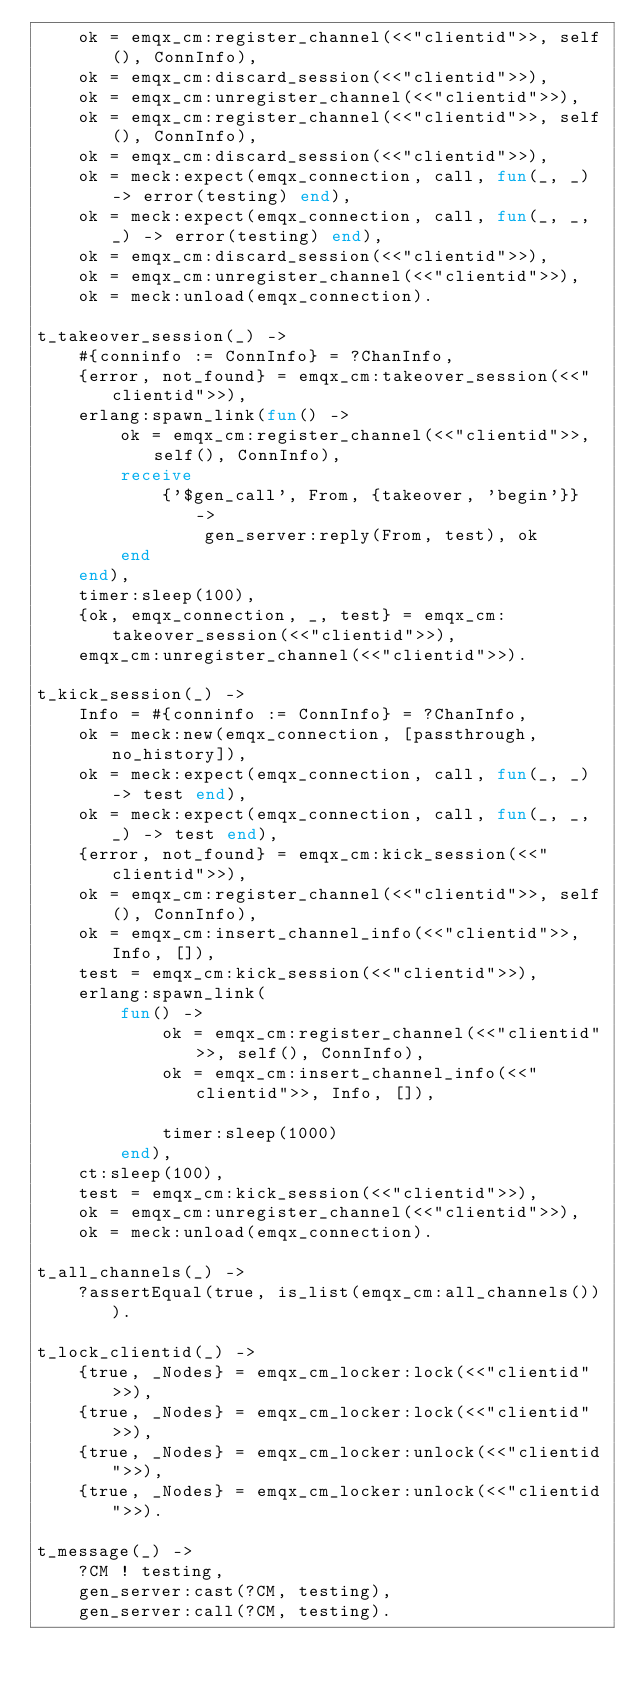Convert code to text. <code><loc_0><loc_0><loc_500><loc_500><_Erlang_>    ok = emqx_cm:register_channel(<<"clientid">>, self(), ConnInfo),
    ok = emqx_cm:discard_session(<<"clientid">>),
    ok = emqx_cm:unregister_channel(<<"clientid">>),
    ok = emqx_cm:register_channel(<<"clientid">>, self(), ConnInfo),
    ok = emqx_cm:discard_session(<<"clientid">>),
    ok = meck:expect(emqx_connection, call, fun(_, _) -> error(testing) end),
    ok = meck:expect(emqx_connection, call, fun(_, _, _) -> error(testing) end),
    ok = emqx_cm:discard_session(<<"clientid">>),
    ok = emqx_cm:unregister_channel(<<"clientid">>),
    ok = meck:unload(emqx_connection).

t_takeover_session(_) ->
    #{conninfo := ConnInfo} = ?ChanInfo,
    {error, not_found} = emqx_cm:takeover_session(<<"clientid">>),
    erlang:spawn_link(fun() ->
        ok = emqx_cm:register_channel(<<"clientid">>, self(), ConnInfo),
        receive
            {'$gen_call', From, {takeover, 'begin'}} ->
                gen_server:reply(From, test), ok
        end
    end),
    timer:sleep(100),
    {ok, emqx_connection, _, test} = emqx_cm:takeover_session(<<"clientid">>),
    emqx_cm:unregister_channel(<<"clientid">>).

t_kick_session(_) ->
    Info = #{conninfo := ConnInfo} = ?ChanInfo,
    ok = meck:new(emqx_connection, [passthrough, no_history]),
    ok = meck:expect(emqx_connection, call, fun(_, _) -> test end),
    ok = meck:expect(emqx_connection, call, fun(_, _, _) -> test end),
    {error, not_found} = emqx_cm:kick_session(<<"clientid">>),
    ok = emqx_cm:register_channel(<<"clientid">>, self(), ConnInfo),
    ok = emqx_cm:insert_channel_info(<<"clientid">>, Info, []),
    test = emqx_cm:kick_session(<<"clientid">>),
    erlang:spawn_link(
        fun() ->
            ok = emqx_cm:register_channel(<<"clientid">>, self(), ConnInfo),
            ok = emqx_cm:insert_channel_info(<<"clientid">>, Info, []),

            timer:sleep(1000)
        end),
    ct:sleep(100),
    test = emqx_cm:kick_session(<<"clientid">>),
    ok = emqx_cm:unregister_channel(<<"clientid">>),
    ok = meck:unload(emqx_connection).

t_all_channels(_) ->
    ?assertEqual(true, is_list(emqx_cm:all_channels())).

t_lock_clientid(_) ->
    {true, _Nodes} = emqx_cm_locker:lock(<<"clientid">>),
    {true, _Nodes} = emqx_cm_locker:lock(<<"clientid">>),
    {true, _Nodes} = emqx_cm_locker:unlock(<<"clientid">>),
    {true, _Nodes} = emqx_cm_locker:unlock(<<"clientid">>).

t_message(_) ->
    ?CM ! testing,
    gen_server:cast(?CM, testing),
    gen_server:call(?CM, testing).
</code> 